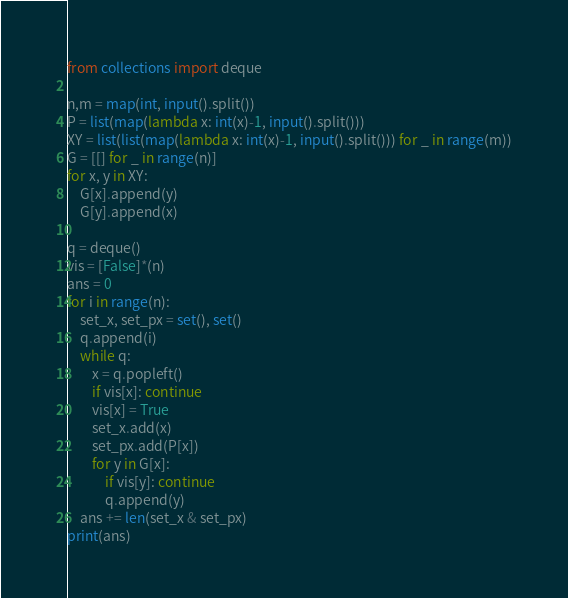<code> <loc_0><loc_0><loc_500><loc_500><_Python_>from collections import deque

n,m = map(int, input().split())
P = list(map(lambda x: int(x)-1, input().split()))
XY = list(list(map(lambda x: int(x)-1, input().split())) for _ in range(m))
G = [[] for _ in range(n)]
for x, y in XY:
    G[x].append(y)
    G[y].append(x)

q = deque()
vis = [False]*(n)
ans = 0
for i in range(n):
    set_x, set_px = set(), set()
    q.append(i)
    while q:
        x = q.popleft()
        if vis[x]: continue
        vis[x] = True
        set_x.add(x)
        set_px.add(P[x])
        for y in G[x]:
            if vis[y]: continue
            q.append(y)
    ans += len(set_x & set_px)
print(ans)
</code> 